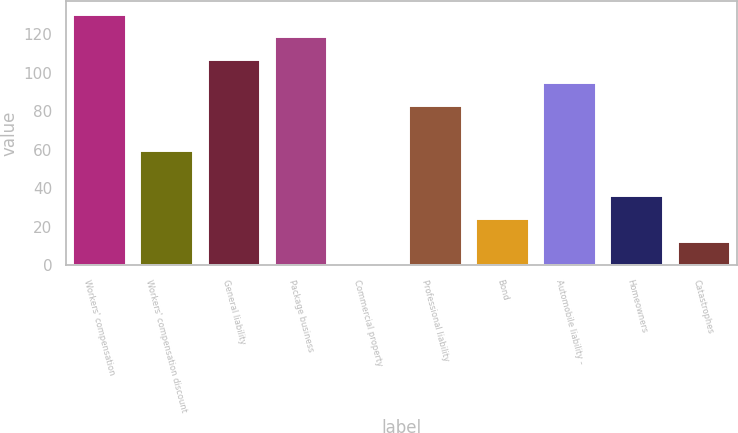Convert chart to OTSL. <chart><loc_0><loc_0><loc_500><loc_500><bar_chart><fcel>Workers' compensation<fcel>Workers' compensation discount<fcel>General liability<fcel>Package business<fcel>Commercial property<fcel>Professional liability<fcel>Bond<fcel>Automobile liability -<fcel>Homeowners<fcel>Catastrophes<nl><fcel>130.8<fcel>60<fcel>107.2<fcel>119<fcel>1<fcel>83.6<fcel>24.6<fcel>95.4<fcel>36.4<fcel>12.8<nl></chart> 